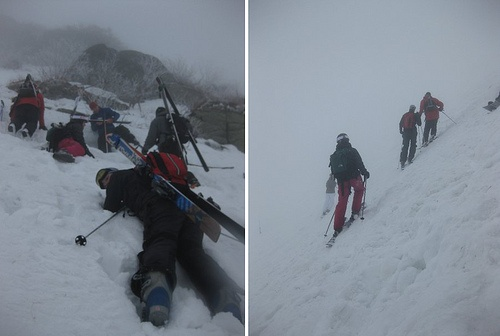Describe the objects in this image and their specific colors. I can see people in gray and black tones, skis in gray, black, navy, and darkblue tones, people in gray, purple, darkblue, and black tones, people in gray, black, and maroon tones, and people in gray, black, and purple tones in this image. 